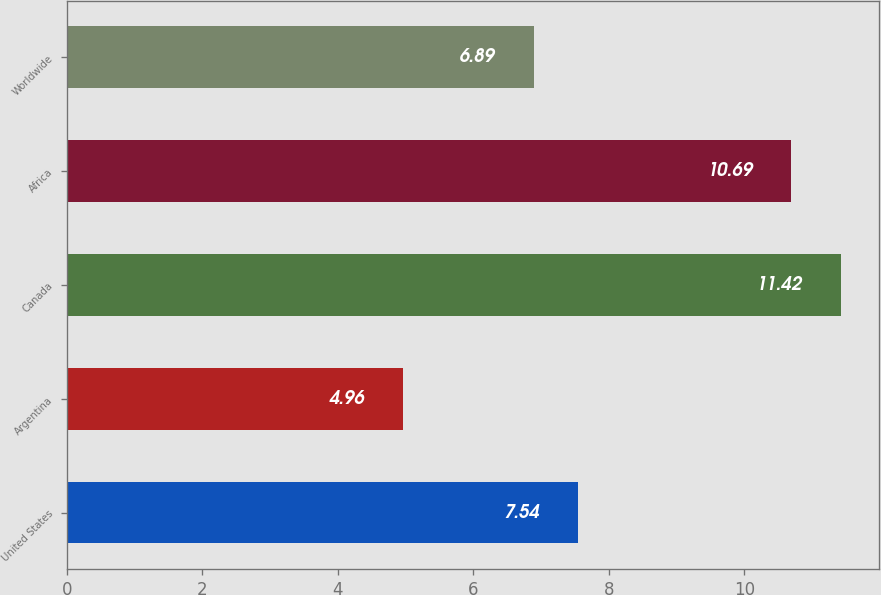Convert chart to OTSL. <chart><loc_0><loc_0><loc_500><loc_500><bar_chart><fcel>United States<fcel>Argentina<fcel>Canada<fcel>Africa<fcel>Worldwide<nl><fcel>7.54<fcel>4.96<fcel>11.42<fcel>10.69<fcel>6.89<nl></chart> 